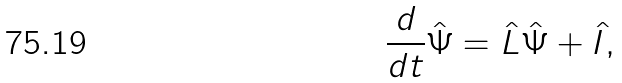Convert formula to latex. <formula><loc_0><loc_0><loc_500><loc_500>\frac { d } { d t } \hat { \Psi } = \hat { L } \hat { \Psi } + \hat { I } ,</formula> 